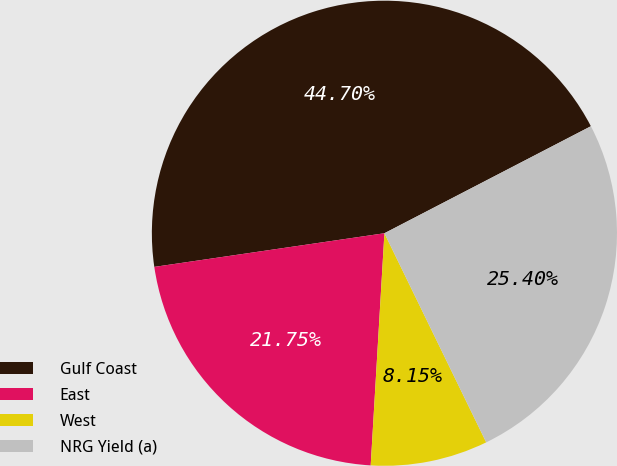<chart> <loc_0><loc_0><loc_500><loc_500><pie_chart><fcel>Gulf Coast<fcel>East<fcel>West<fcel>NRG Yield (a)<nl><fcel>44.7%<fcel>21.75%<fcel>8.15%<fcel>25.4%<nl></chart> 